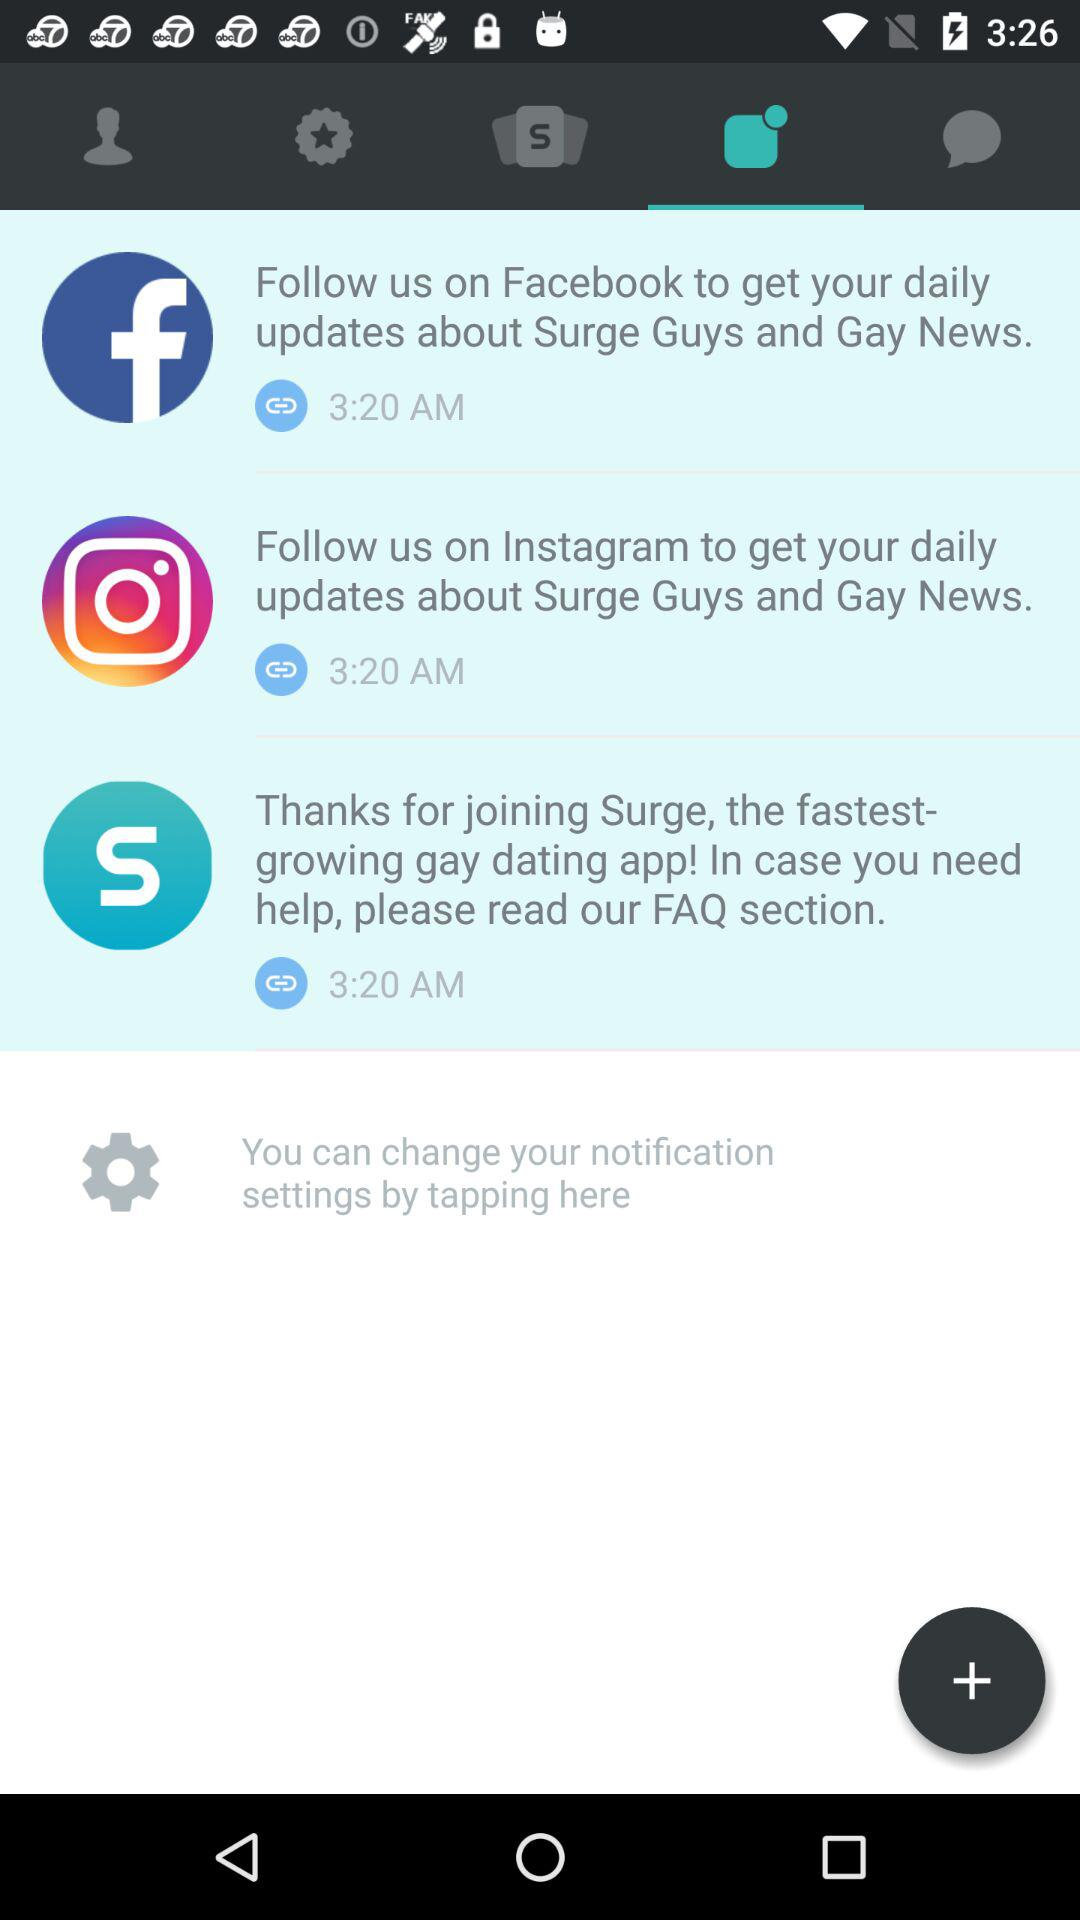What is the mentioned time? The mentioned time is 3:20 AM. 